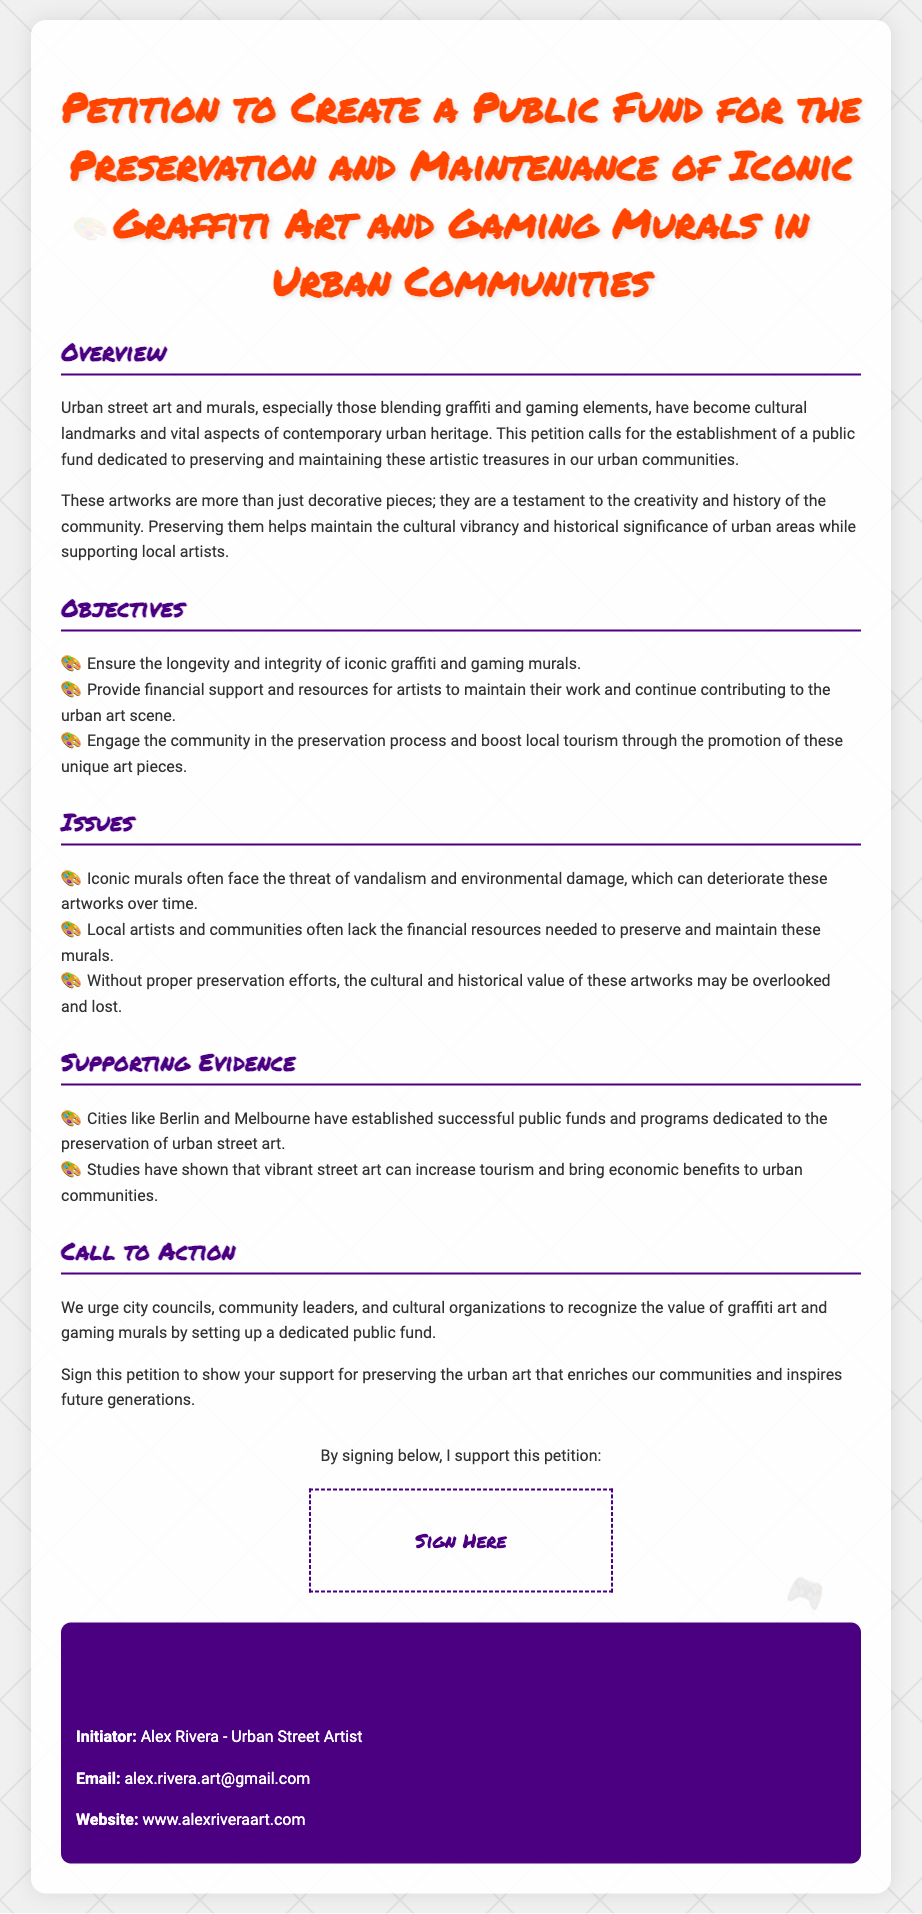What is the title of the petition? The title of the petition can be found at the top of the document.
Answer: Petition to Create a Public Fund for the Preservation and Maintenance of Iconic Graffiti Art and Gaming Murals in Urban Communities Who is the initiator of the petition? The initiator's name is listed in the contact information section of the document.
Answer: Alex Rivera What is one of the major objectives of the petition? The objectives are listed under the Objectives section, which includes several goals.
Answer: Ensure the longevity and integrity of iconic graffiti and gaming murals What issue do iconic murals face according to the petition? The issues are outlined in a specific section that describes problems related to the murals.
Answer: Vandalism and environmental damage Which cities are mentioned as examples for successful public funds? The supporting evidence section lists cities that have undertaken similar initiatives.
Answer: Berlin and Melbourne What type of support is requested from city councils? The call to action specifies what is being urged from community leaders and organizations.
Answer: Establish a dedicated public fund How is the petition visually represented on the document? The visual aspect is evident through the use of specific styles and design elements indicated in the code.
Answer: Graffiti art and gaming murals What platform can people use to contact the petition initiator? The contact information section provides details on how to connect with Alex Rivera.
Answer: Email What is the purpose of the signature area? The signature area is defined in the document to gather support for the petition.
Answer: Support this petition 